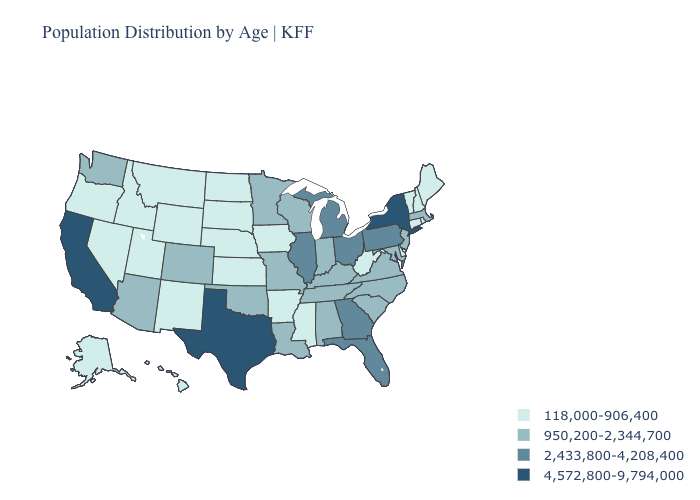What is the lowest value in the South?
Write a very short answer. 118,000-906,400. What is the value of Vermont?
Be succinct. 118,000-906,400. Name the states that have a value in the range 2,433,800-4,208,400?
Concise answer only. Florida, Georgia, Illinois, Michigan, Ohio, Pennsylvania. Does Kansas have the lowest value in the USA?
Short answer required. Yes. Name the states that have a value in the range 118,000-906,400?
Short answer required. Alaska, Arkansas, Connecticut, Delaware, Hawaii, Idaho, Iowa, Kansas, Maine, Mississippi, Montana, Nebraska, Nevada, New Hampshire, New Mexico, North Dakota, Oregon, Rhode Island, South Dakota, Utah, Vermont, West Virginia, Wyoming. Does New Mexico have the same value as New Hampshire?
Keep it brief. Yes. Which states have the highest value in the USA?
Be succinct. California, New York, Texas. What is the highest value in states that border Maine?
Answer briefly. 118,000-906,400. What is the lowest value in the MidWest?
Give a very brief answer. 118,000-906,400. What is the lowest value in states that border New Mexico?
Short answer required. 118,000-906,400. What is the value of New York?
Concise answer only. 4,572,800-9,794,000. What is the highest value in the West ?
Give a very brief answer. 4,572,800-9,794,000. Which states have the lowest value in the MidWest?
Short answer required. Iowa, Kansas, Nebraska, North Dakota, South Dakota. Among the states that border Florida , which have the lowest value?
Concise answer only. Alabama. Which states have the highest value in the USA?
Write a very short answer. California, New York, Texas. 